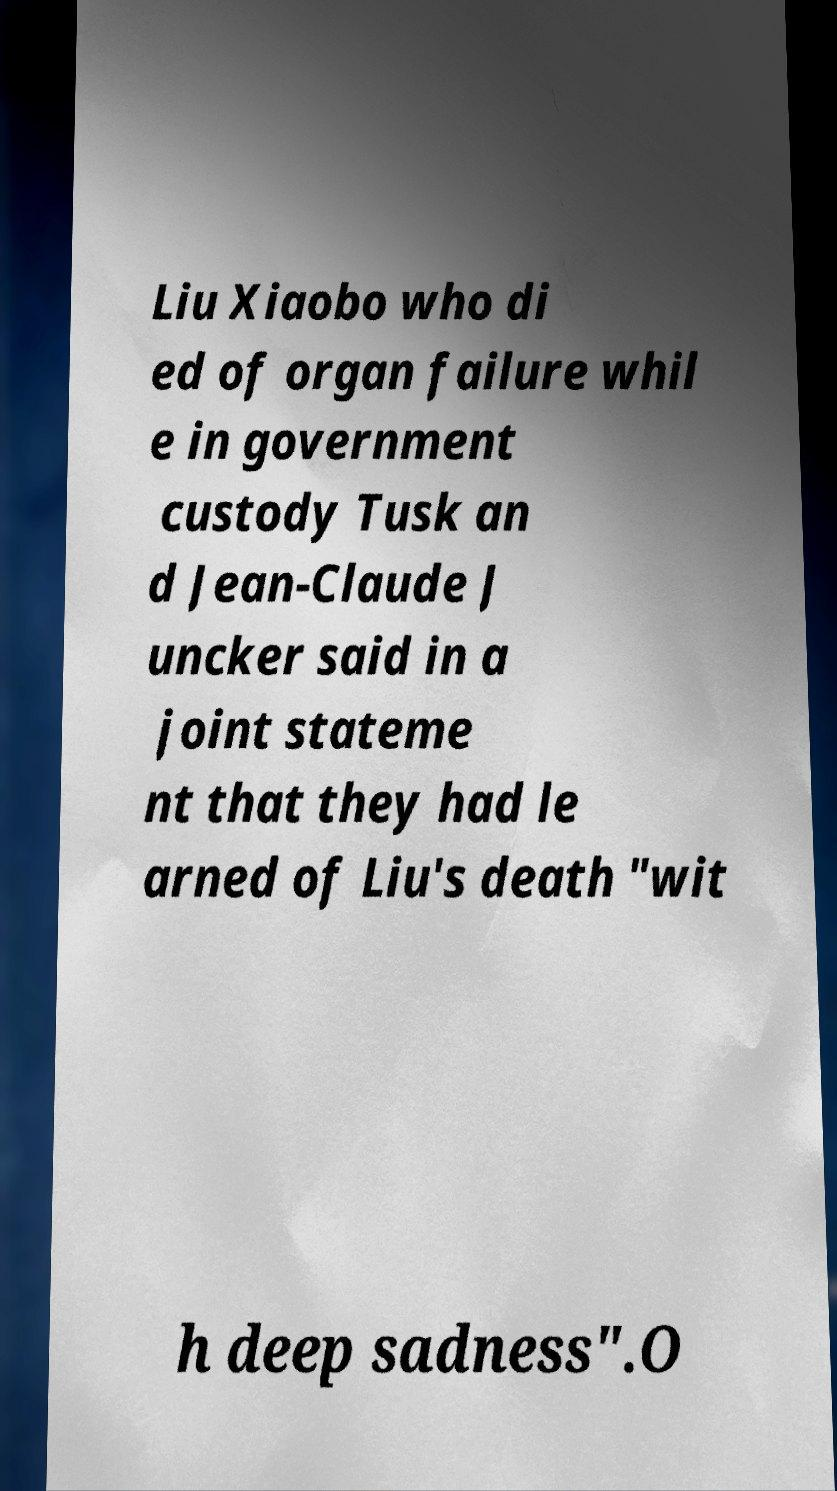For documentation purposes, I need the text within this image transcribed. Could you provide that? Liu Xiaobo who di ed of organ failure whil e in government custody Tusk an d Jean-Claude J uncker said in a joint stateme nt that they had le arned of Liu's death "wit h deep sadness".O 